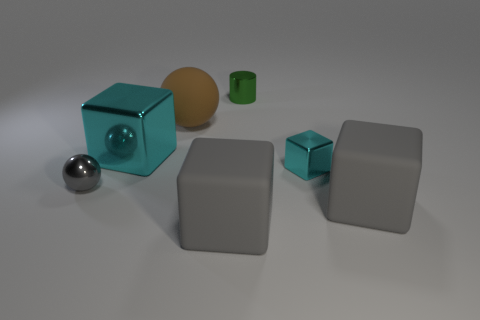What material do the objects appear to be made from? The objects seem to have a matte finish and appear to be made of a rigid material, possibly a type of plastic or metal, judging by the light reflections and shadows. 